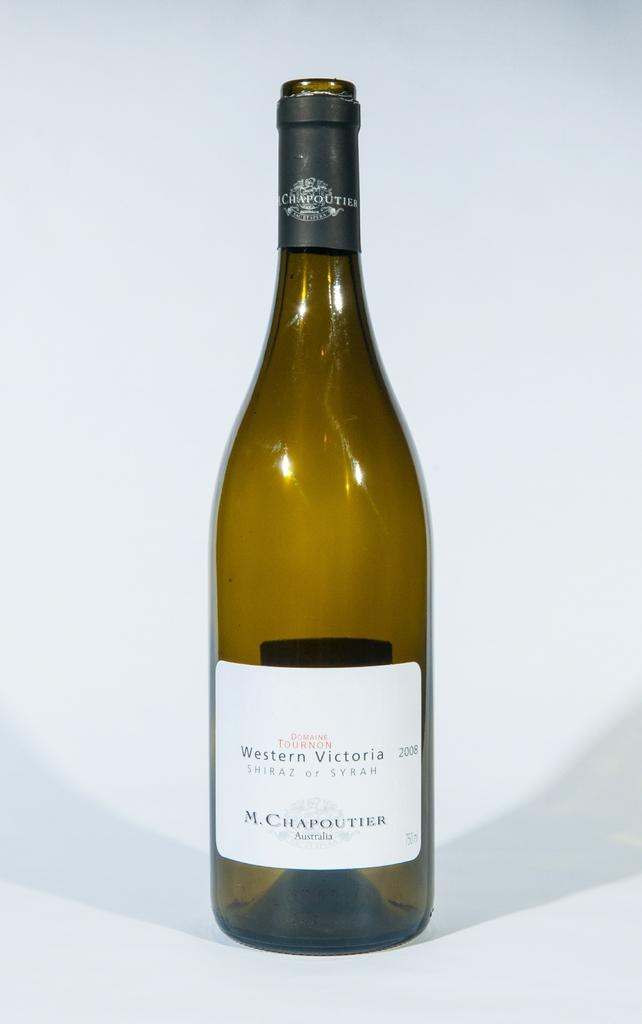<image>
Relay a brief, clear account of the picture shown. A bottle of Wetern Victoria Syrah wine made in Australia. 